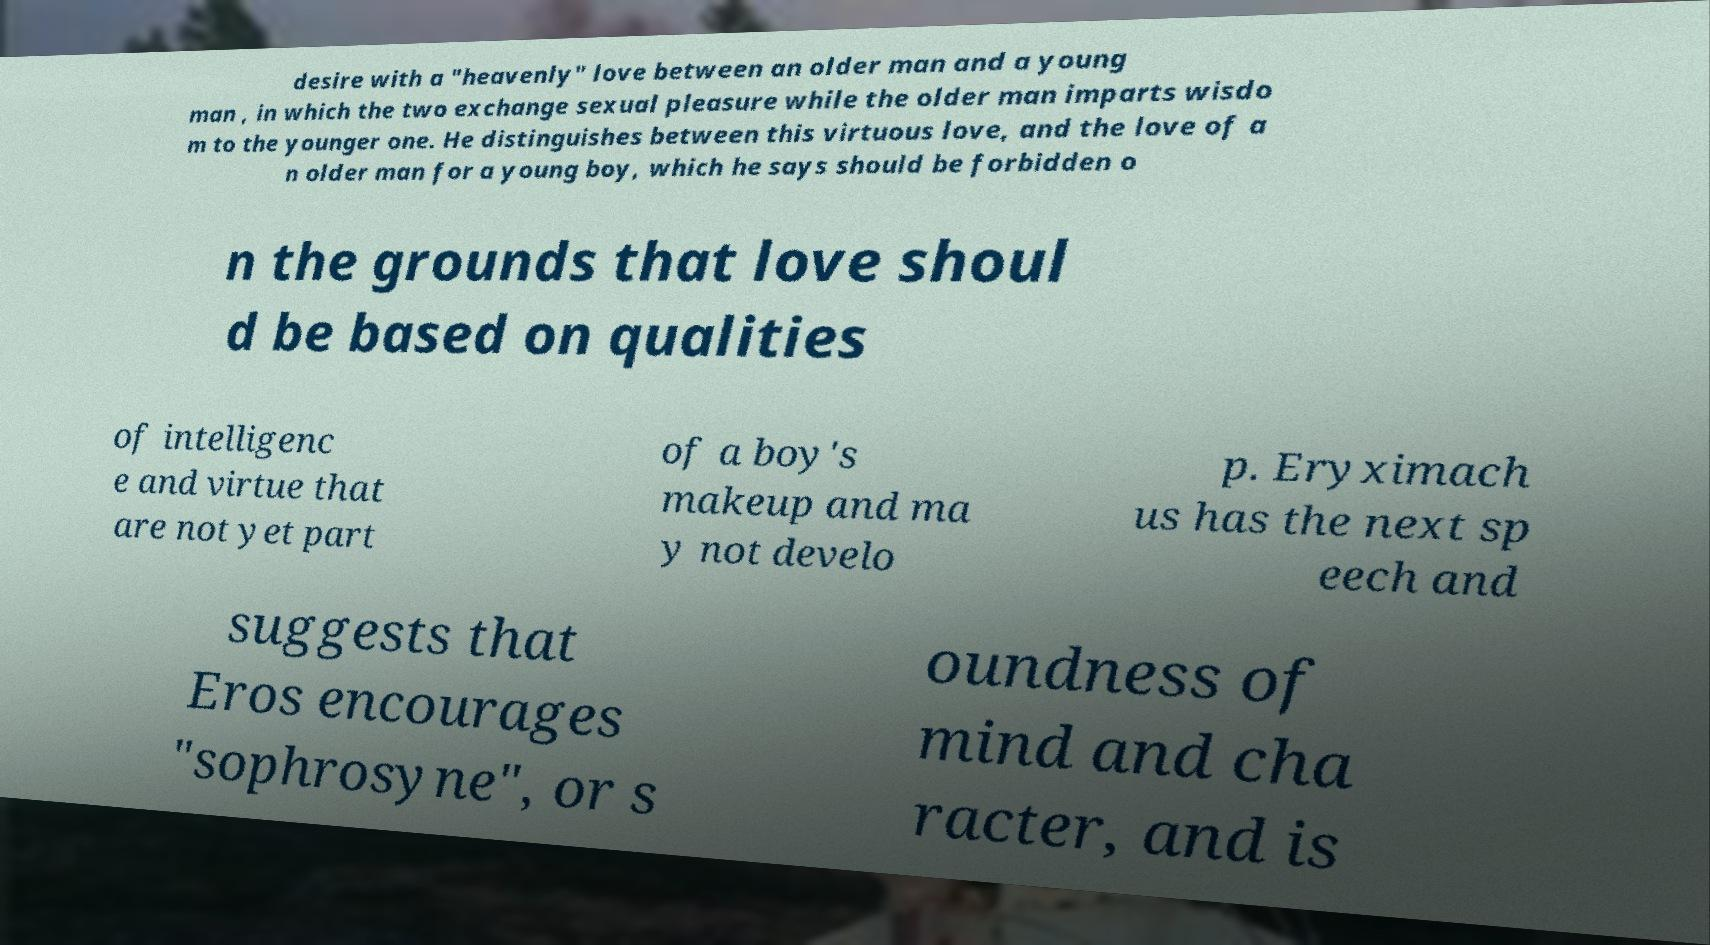Can you read and provide the text displayed in the image?This photo seems to have some interesting text. Can you extract and type it out for me? desire with a "heavenly" love between an older man and a young man , in which the two exchange sexual pleasure while the older man imparts wisdo m to the younger one. He distinguishes between this virtuous love, and the love of a n older man for a young boy, which he says should be forbidden o n the grounds that love shoul d be based on qualities of intelligenc e and virtue that are not yet part of a boy's makeup and ma y not develo p. Eryximach us has the next sp eech and suggests that Eros encourages "sophrosyne", or s oundness of mind and cha racter, and is 